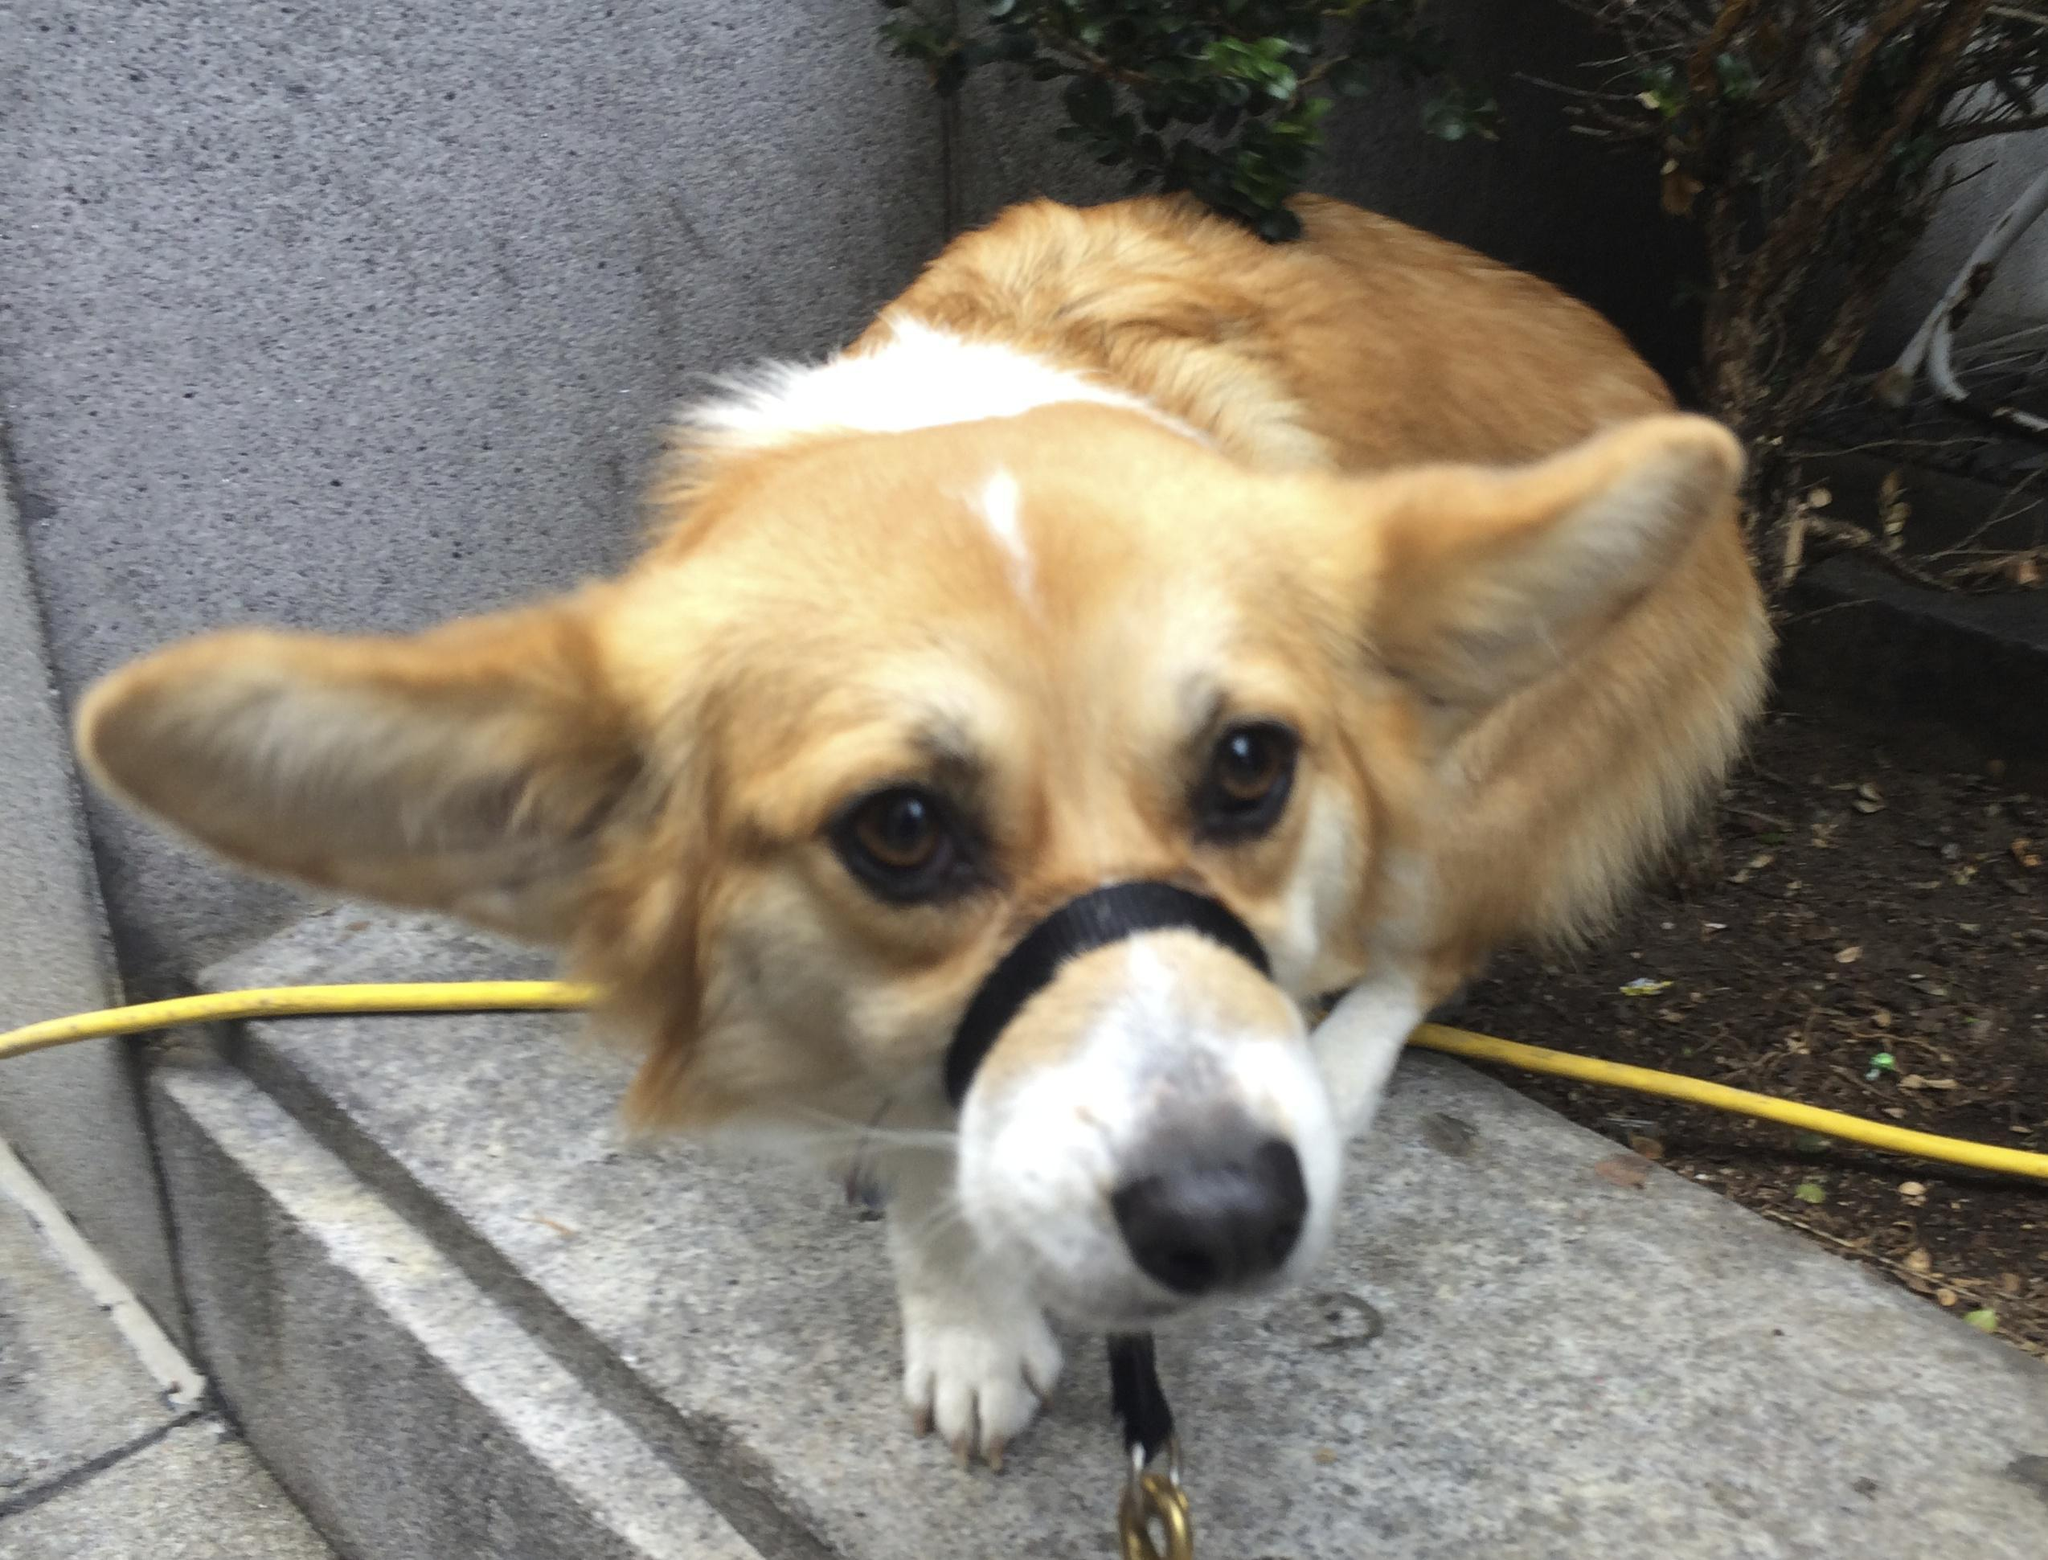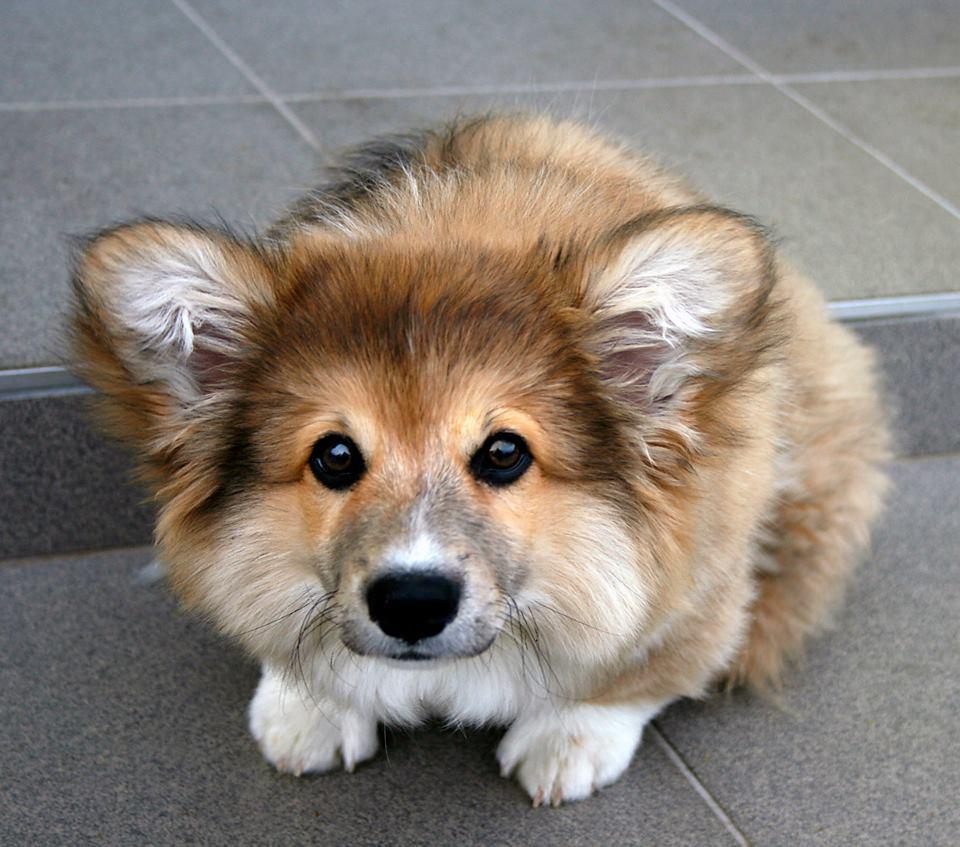The first image is the image on the left, the second image is the image on the right. Considering the images on both sides, is "The dog in the image on the right is on a leasch" valid? Answer yes or no. No. 